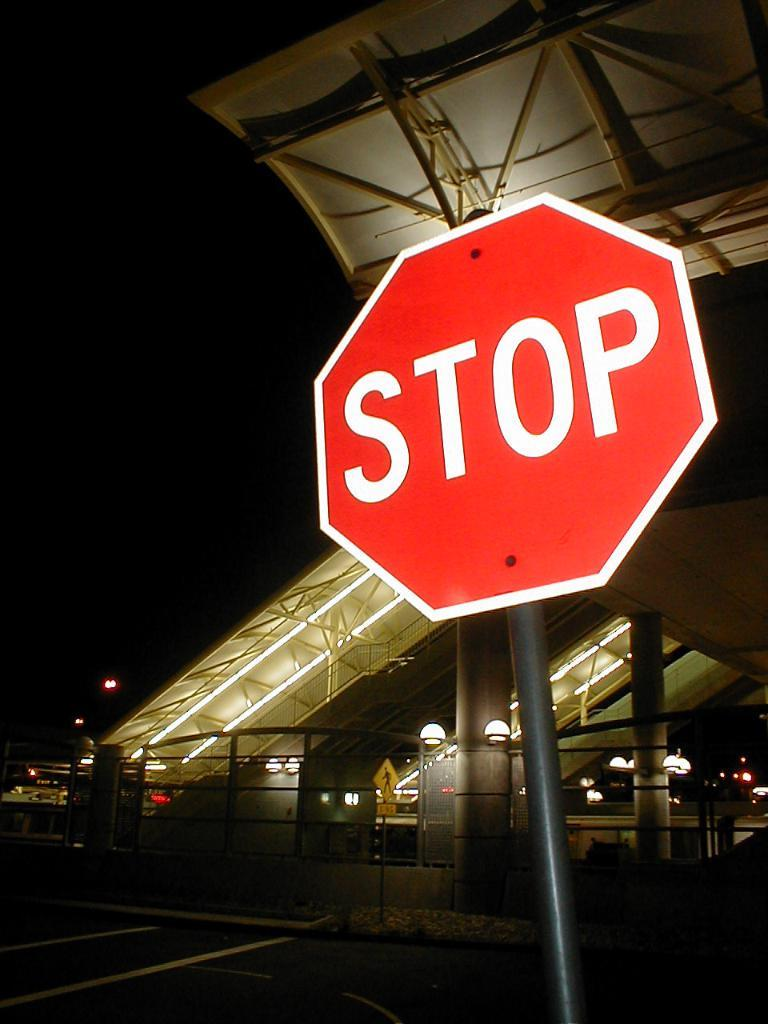Provide a one-sentence caption for the provided image. Bright Stop sign in front of a big building. 